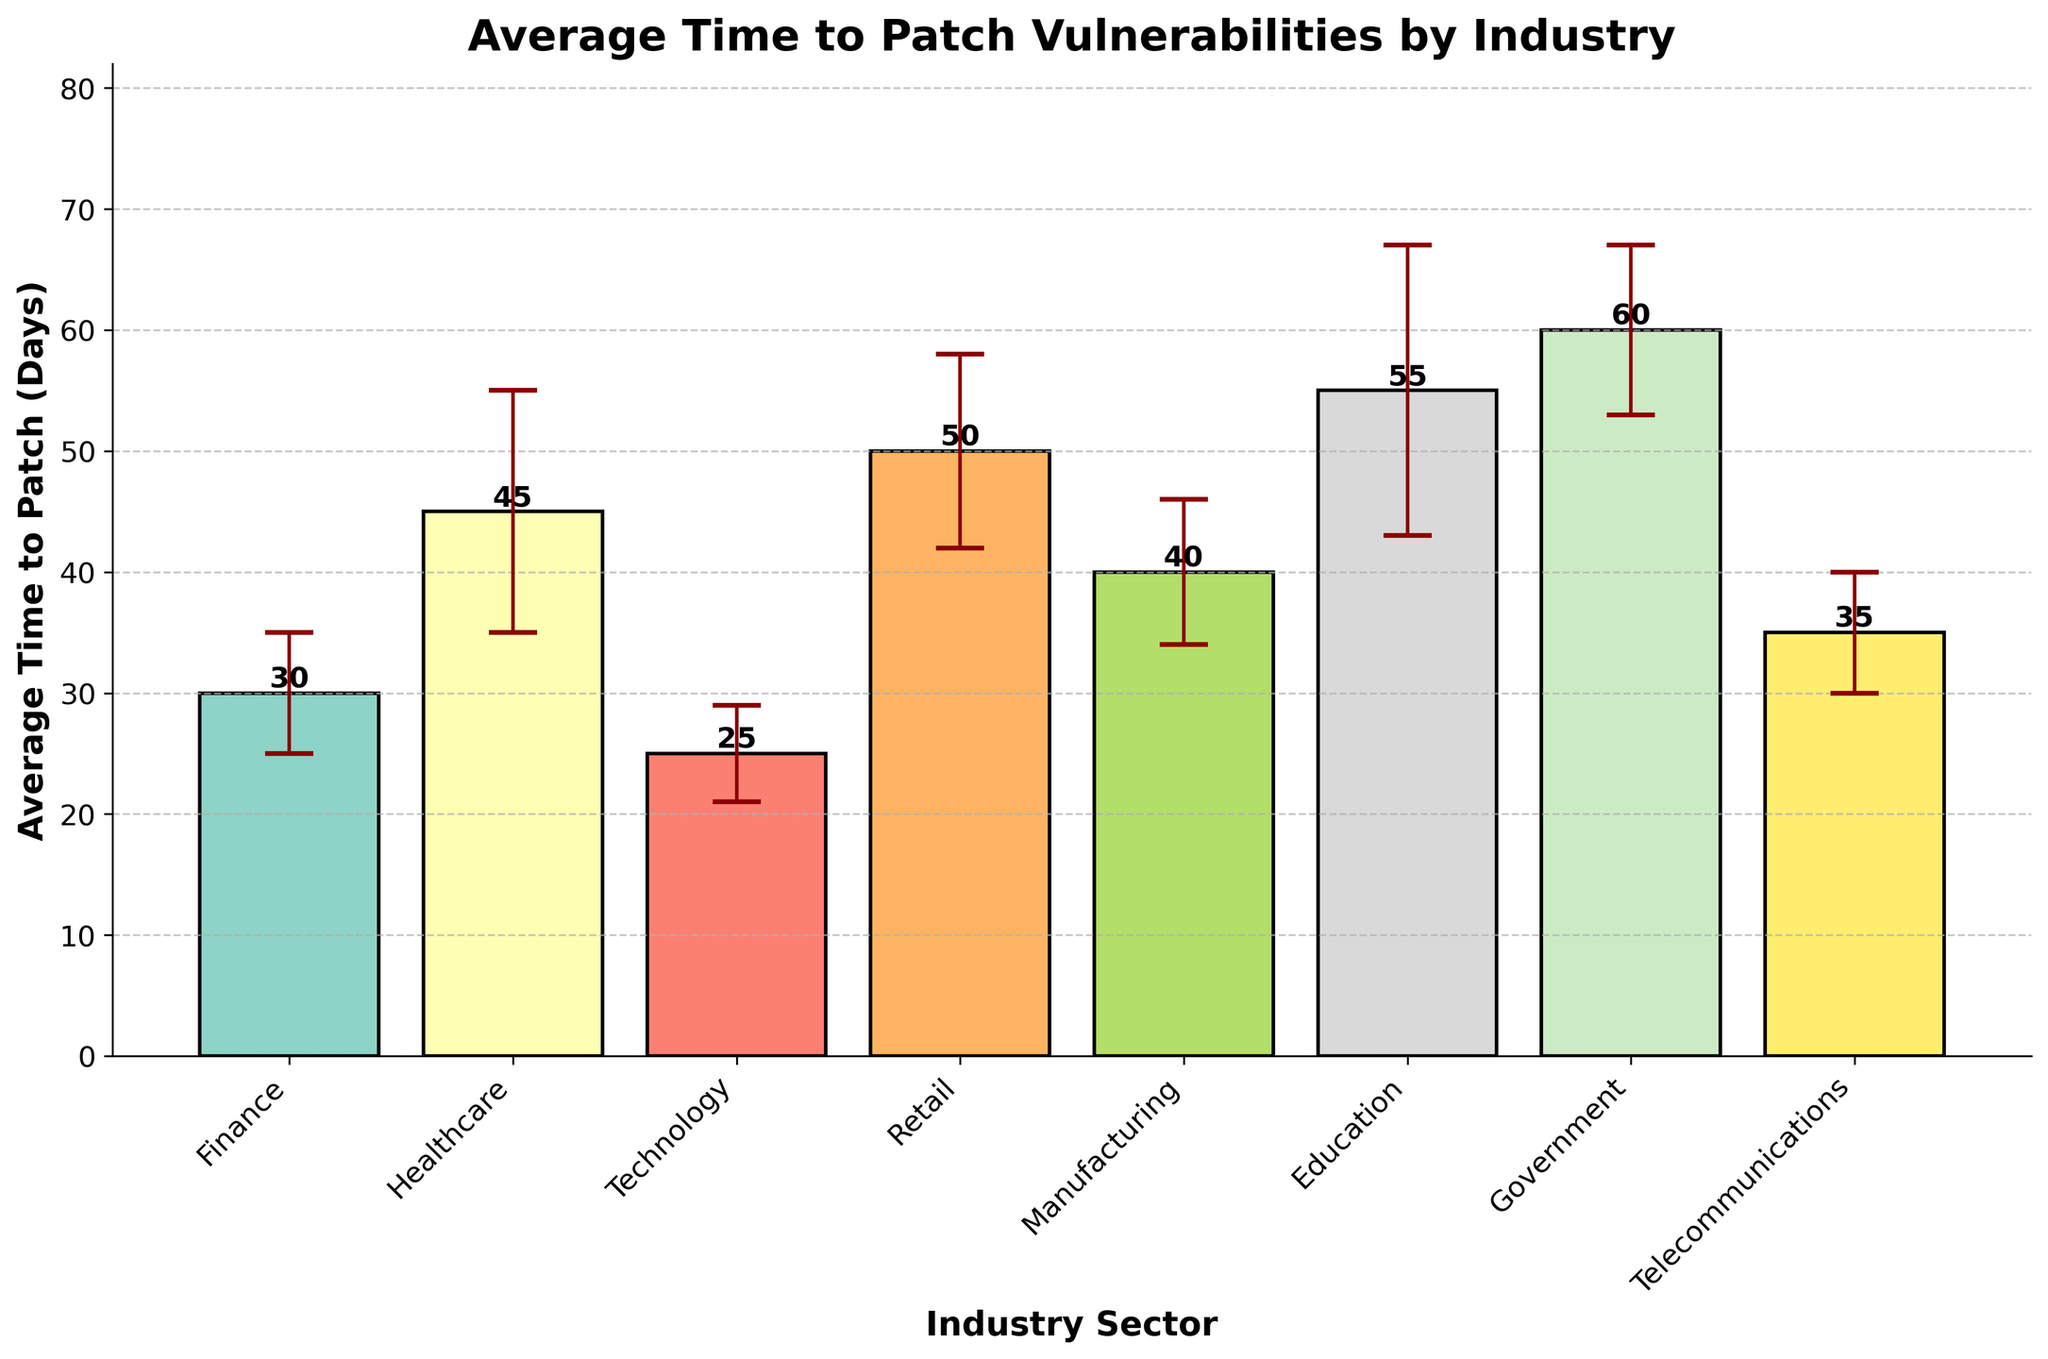What is the title of the plot? The title of the plot is displayed prominently at the top. Reading it directly from the figure, it says: "Average Time to Patch Vulnerabilities by Industry."
Answer: "Average Time to Patch Vulnerabilities by Industry" Which industry sector has the longest average time to patch vulnerabilities? The bars in the plot represent different industry sectors, and the height of the bar shows the average time to patch. The highest bar corresponds to the "Government" sector.
Answer: Government What is the average time to patch vulnerabilities in the Technology sector? The bar corresponding to the Technology sector indicates the average time to patch vulnerabilities. By reading the label at the top of the bar, we see that it is 25 days.
Answer: 25 days How many industry sectors have an average time to patch vulnerabilities of 50 days or more? We check the height of each bar to identify those that are at or above 50 days. There are four such bars: Retail (50 days), Education (55 days), and Government (60 days).
Answer: 3 sectors What is the difference in the average time to patch vulnerabilities between the Finance and Education sectors? The average time to patch for Finance is 30 days, and for Education, it is 55 days. Subtract 30 from 55 to get the difference.
Answer: 25 days Which industry sector has the smallest standard deviation in time to patch vulnerabilities? The size of the error bars represents the standard deviations. By comparing the lengths of the error bars, the Technology sector has the smallest standard deviation (4 days).
Answer: Technology Is the standard deviation for the Healthcare sector greater than that for the Finance sector? Compare the lengths of the error bars for Healthcare (10 days) and Finance (5 days). Healthcare's standard deviation is greater.
Answer: Yes How many sectors have a standard deviation of 7 days or more? By observing the lengths of the error bars, we identify that Healthcare (10), Retail (8), Education (12), Government (7), and Manufacturing (6) each have a standard deviation of 7 days or more.
Answer: 4 sectors If every industry sector reduces its average patch time by 5 days, which sector would then have the lowest average time to patch? Reduce each sector's average time by 5 days. Technology, originally 25 days, would be reduced to 20 days, which remains the lowest.
Answer: Technology What is the range of average patch times across all industry sectors? The range is found by subtracting the smallest average patch time (Technology, 25 days) from the largest (Government, 60 days). 60 - 25 = 35 days.
Answer: 35 days 